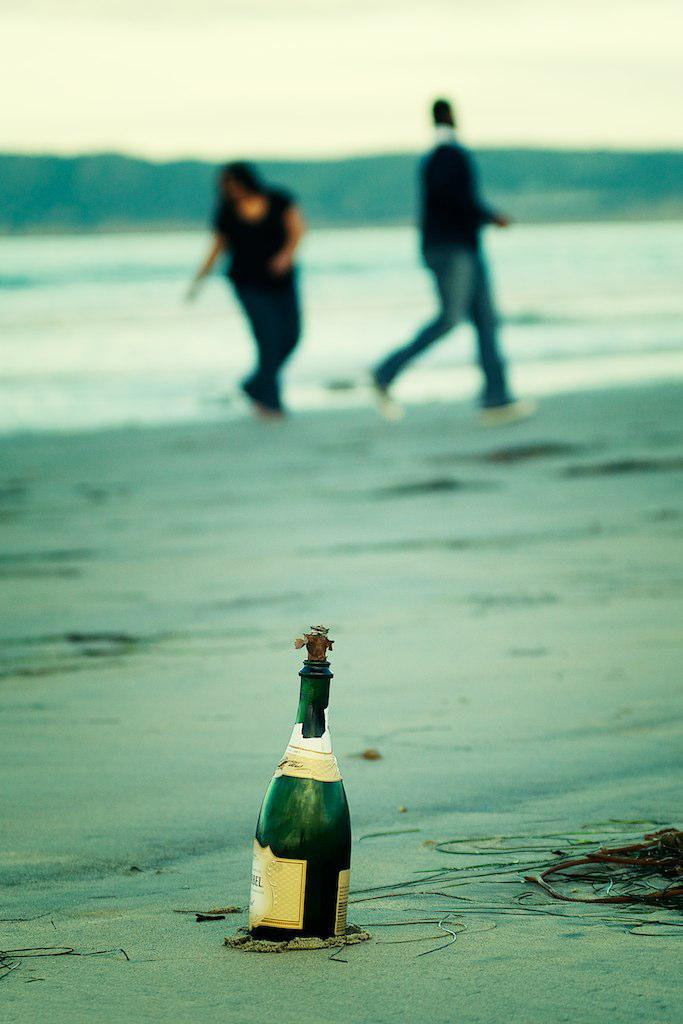What type of location is shown in the image? The image depicts a beach. What object can be seen on the beach? There is a bottle on the beach. What activity are the two persons in the background engaged in? The two persons in the background are running. What natural element is visible in the image? There is water visible in the image. What part of the environment is visible above the beach? The sky is visible in the image. What type of kettle can be seen boiling water on the beach in the image? There is no kettle present in the image; it depicts a beach with a bottle, running persons, water, and the sky. Can you tell me how many pickles are lying on the sand in the image? There are no pickles present in the image; it only shows a beach with a bottle, running persons, water, and the sky. 